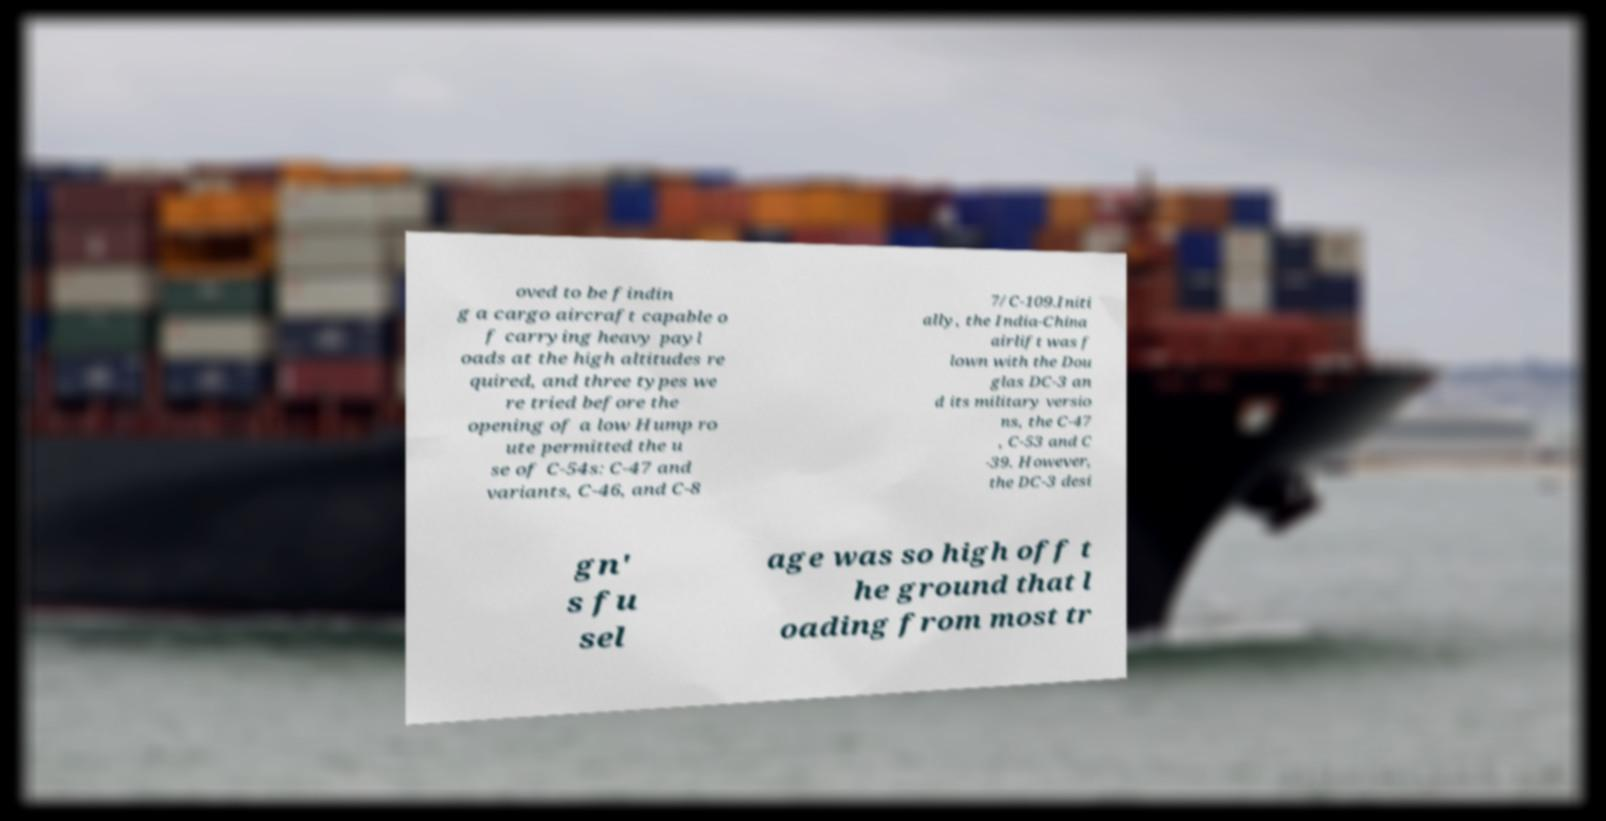Could you extract and type out the text from this image? oved to be findin g a cargo aircraft capable o f carrying heavy payl oads at the high altitudes re quired, and three types we re tried before the opening of a low Hump ro ute permitted the u se of C-54s: C-47 and variants, C-46, and C-8 7/C-109.Initi ally, the India-China airlift was f lown with the Dou glas DC-3 an d its military versio ns, the C-47 , C-53 and C -39. However, the DC-3 desi gn' s fu sel age was so high off t he ground that l oading from most tr 